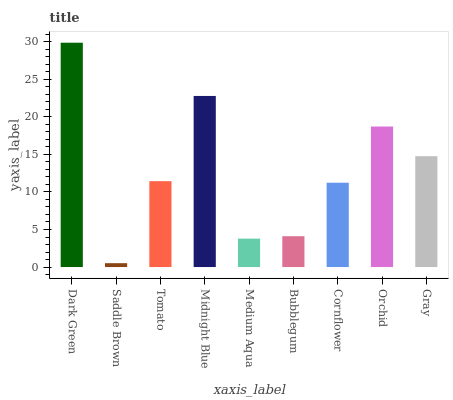Is Saddle Brown the minimum?
Answer yes or no. Yes. Is Dark Green the maximum?
Answer yes or no. Yes. Is Tomato the minimum?
Answer yes or no. No. Is Tomato the maximum?
Answer yes or no. No. Is Tomato greater than Saddle Brown?
Answer yes or no. Yes. Is Saddle Brown less than Tomato?
Answer yes or no. Yes. Is Saddle Brown greater than Tomato?
Answer yes or no. No. Is Tomato less than Saddle Brown?
Answer yes or no. No. Is Tomato the high median?
Answer yes or no. Yes. Is Tomato the low median?
Answer yes or no. Yes. Is Cornflower the high median?
Answer yes or no. No. Is Gray the low median?
Answer yes or no. No. 